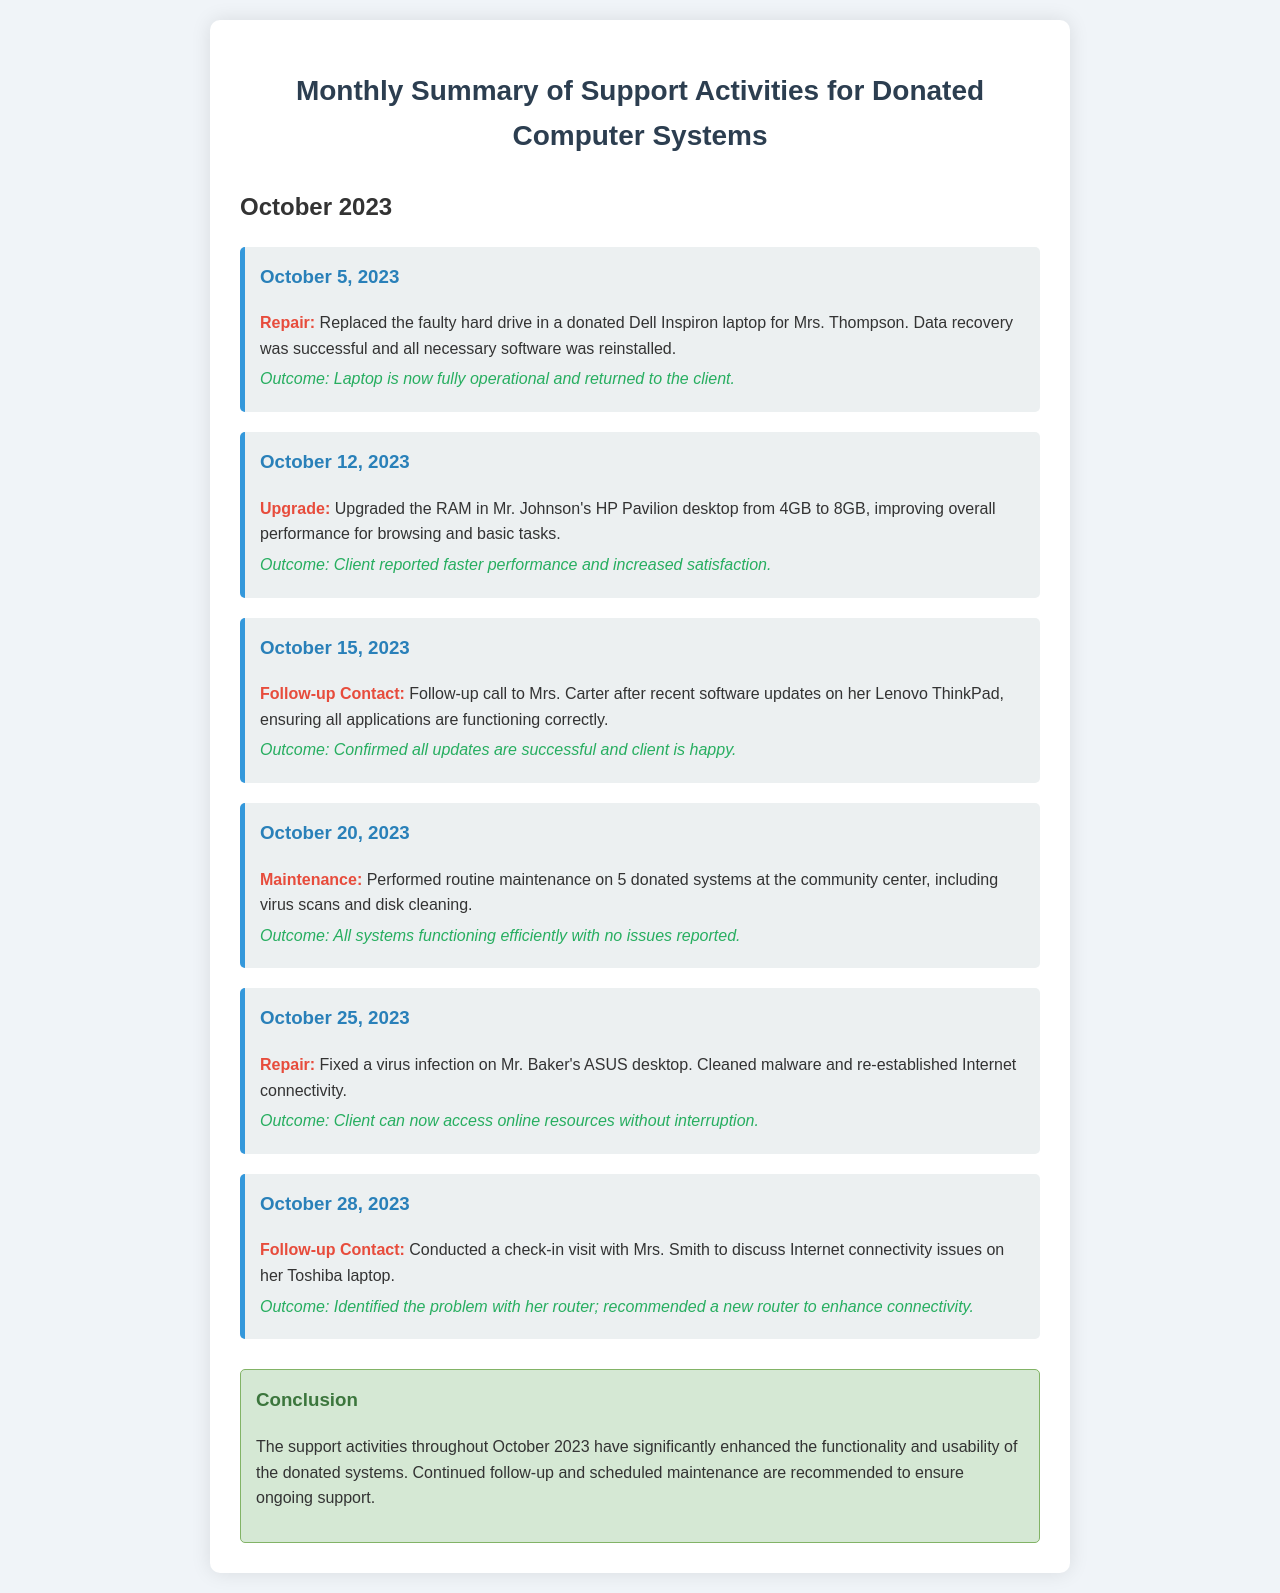What was repaired on October 5, 2023? The document states that the faulty hard drive in a donated Dell Inspiron laptop was replaced.
Answer: Faulty hard drive What improvement was made to Mr. Johnson's HP Pavilion desktop? The document notes the RAM was upgraded from 4GB to 8GB, enhancing performance.
Answer: RAM upgrade What did Mrs. Carter confirm during the follow-up contact? It was confirmed that all updates were successful and the client was happy.
Answer: All updates successful How many systems received routine maintenance on October 20, 2023? The maintenance activity involved 5 donated systems, as mentioned in the document.
Answer: 5 systems What virus issue was resolved on Mr. Baker's ASUS desktop? The document states that a virus infection was fixed, restoring Internet connectivity.
Answer: Virus infection What recommendation was made after the visit with Mrs. Smith? The document suggests recommending a new router to enhance Internet connectivity.
Answer: New router What is the overall conclusion of the support activities in October 2023? The conclusion states that the support activities significantly enhanced functionality and usability.
Answer: Enhanced functionality What date was the follow-up contact with Mrs. Smith conducted? The follow-up contact took place on October 28, 2023.
Answer: October 28, 2023 What activity was performed on October 20, 2023? The document describes that routine maintenance was performed on 5 donated systems.
Answer: Routine maintenance 